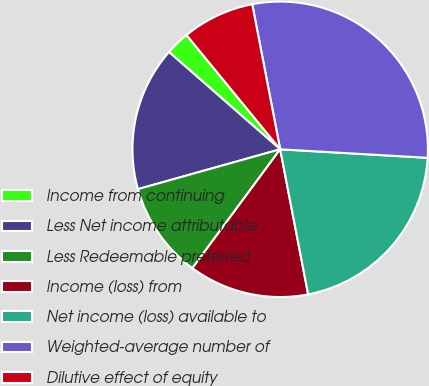<chart> <loc_0><loc_0><loc_500><loc_500><pie_chart><fcel>Income from continuing<fcel>Less Net income attributable<fcel>Less Redeemable preferred<fcel>Income (loss) from<fcel>Net income (loss) available to<fcel>Weighted-average number of<fcel>Dilutive effect of equity<nl><fcel>2.63%<fcel>15.79%<fcel>10.53%<fcel>13.16%<fcel>21.05%<fcel>28.95%<fcel>7.9%<nl></chart> 